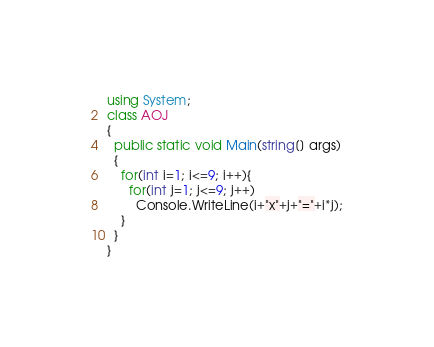Convert code to text. <code><loc_0><loc_0><loc_500><loc_500><_C#_>using System;
class AOJ
{
  public static void Main(string[] args)
  {
    for(int i=1; i<=9; i++){
      for(int j=1; j<=9; j++)
        Console.WriteLine(i+"x"+j+"="+i*j);
	}
  }
}</code> 